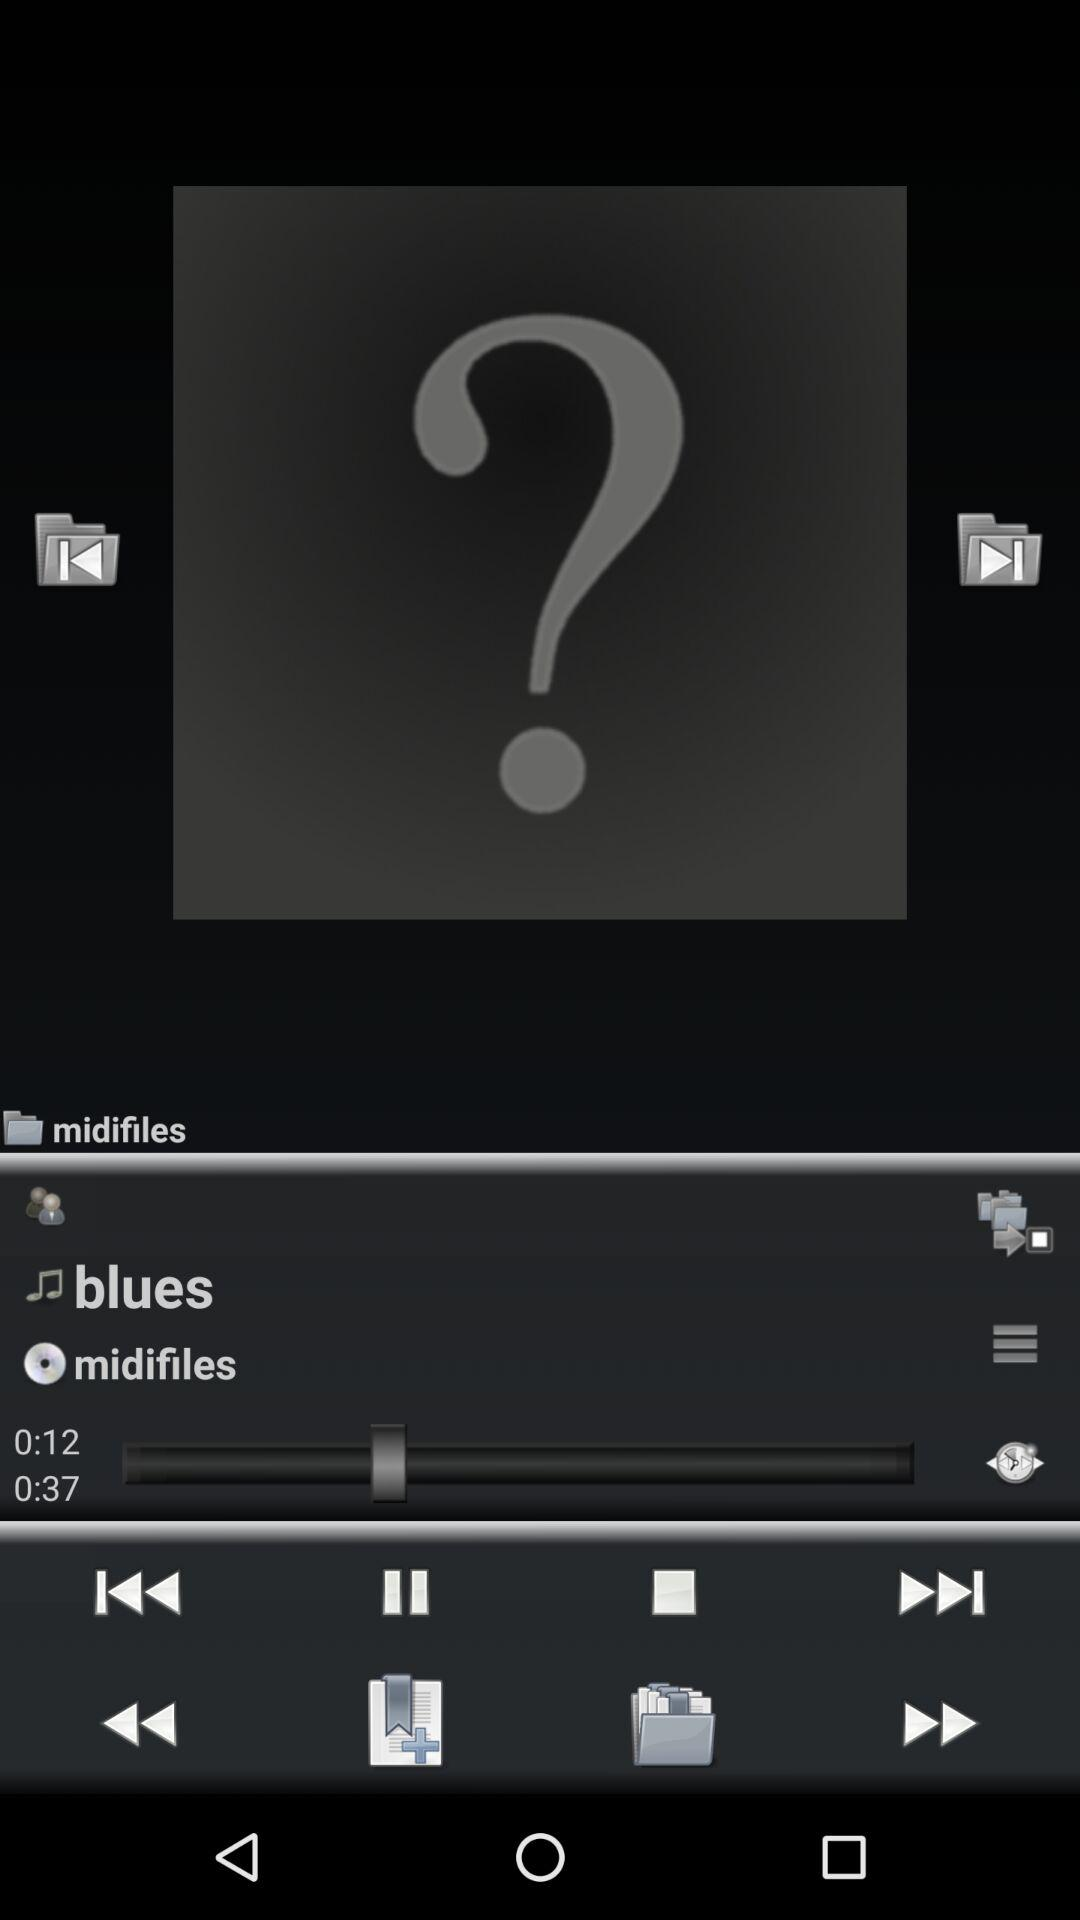What is the folder name? The folder name is "midifiles". 